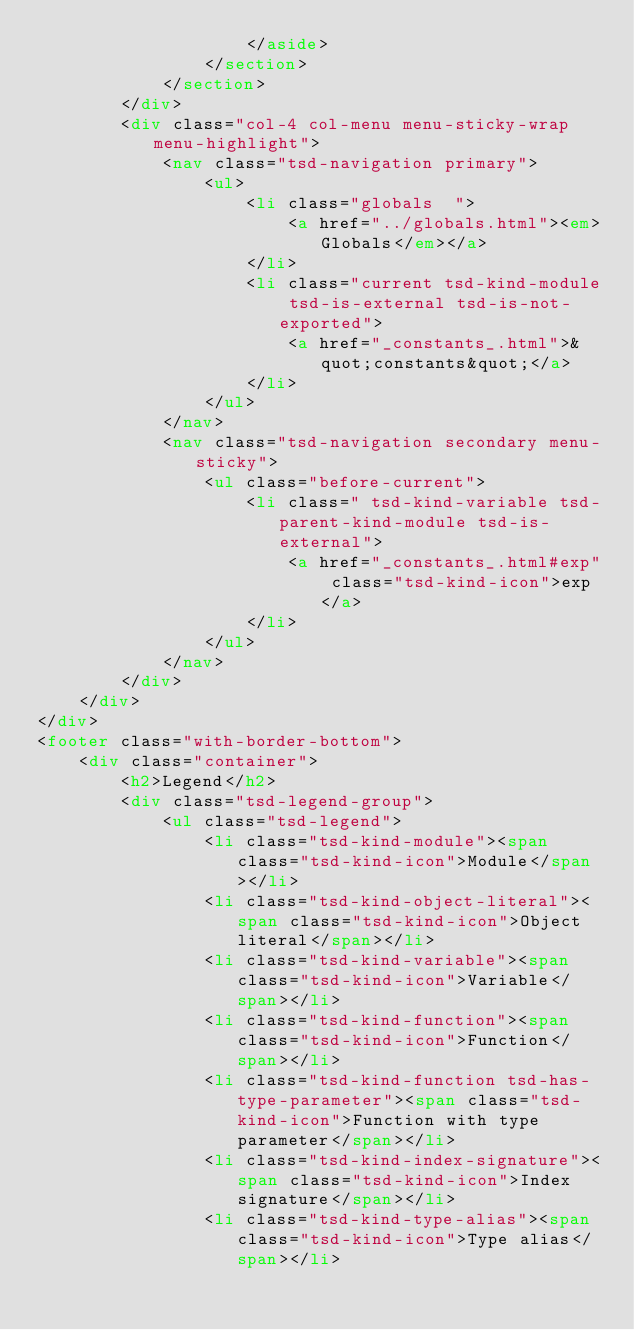<code> <loc_0><loc_0><loc_500><loc_500><_HTML_>					</aside>
				</section>
			</section>
		</div>
		<div class="col-4 col-menu menu-sticky-wrap menu-highlight">
			<nav class="tsd-navigation primary">
				<ul>
					<li class="globals  ">
						<a href="../globals.html"><em>Globals</em></a>
					</li>
					<li class="current tsd-kind-module tsd-is-external tsd-is-not-exported">
						<a href="_constants_.html">&quot;constants&quot;</a>
					</li>
				</ul>
			</nav>
			<nav class="tsd-navigation secondary menu-sticky">
				<ul class="before-current">
					<li class=" tsd-kind-variable tsd-parent-kind-module tsd-is-external">
						<a href="_constants_.html#exp" class="tsd-kind-icon">exp</a>
					</li>
				</ul>
			</nav>
		</div>
	</div>
</div>
<footer class="with-border-bottom">
	<div class="container">
		<h2>Legend</h2>
		<div class="tsd-legend-group">
			<ul class="tsd-legend">
				<li class="tsd-kind-module"><span class="tsd-kind-icon">Module</span></li>
				<li class="tsd-kind-object-literal"><span class="tsd-kind-icon">Object literal</span></li>
				<li class="tsd-kind-variable"><span class="tsd-kind-icon">Variable</span></li>
				<li class="tsd-kind-function"><span class="tsd-kind-icon">Function</span></li>
				<li class="tsd-kind-function tsd-has-type-parameter"><span class="tsd-kind-icon">Function with type parameter</span></li>
				<li class="tsd-kind-index-signature"><span class="tsd-kind-icon">Index signature</span></li>
				<li class="tsd-kind-type-alias"><span class="tsd-kind-icon">Type alias</span></li></code> 